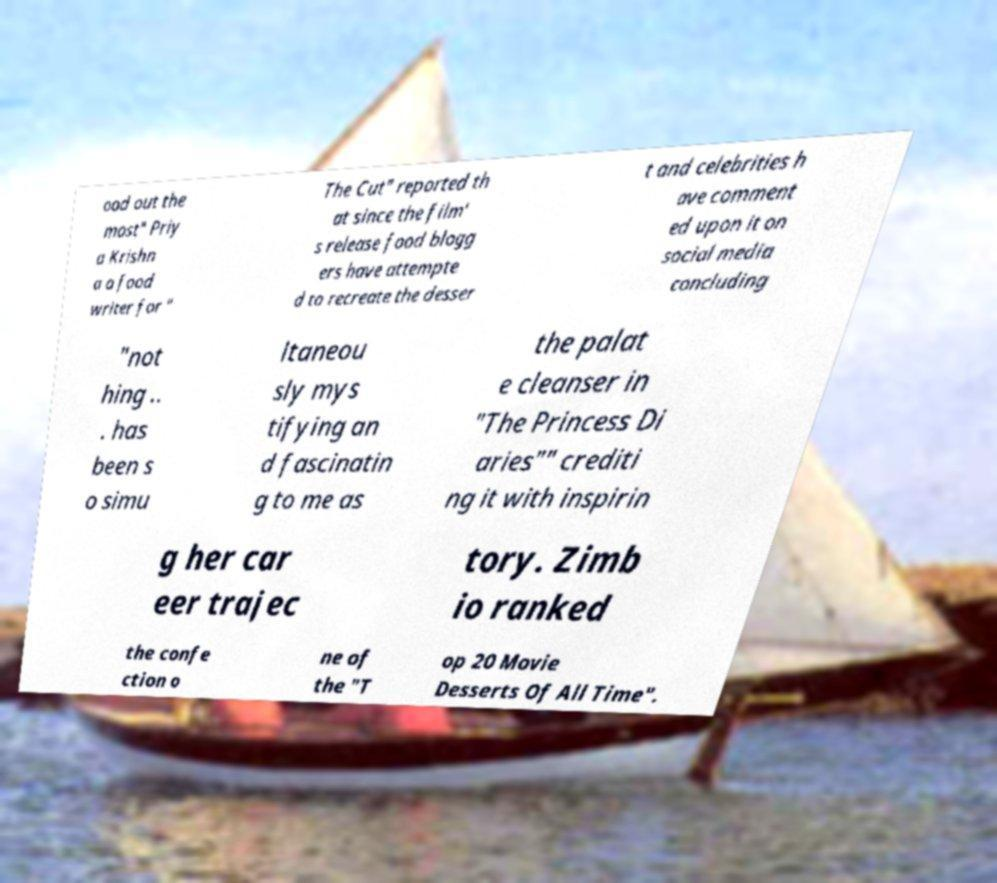Please identify and transcribe the text found in this image. ood out the most" Priy a Krishn a a food writer for " The Cut" reported th at since the film' s release food blogg ers have attempte d to recreate the desser t and celebrities h ave comment ed upon it on social media concluding "not hing .. . has been s o simu ltaneou sly mys tifying an d fascinatin g to me as the palat e cleanser in "The Princess Di aries"" crediti ng it with inspirin g her car eer trajec tory. Zimb io ranked the confe ction o ne of the "T op 20 Movie Desserts Of All Time". 